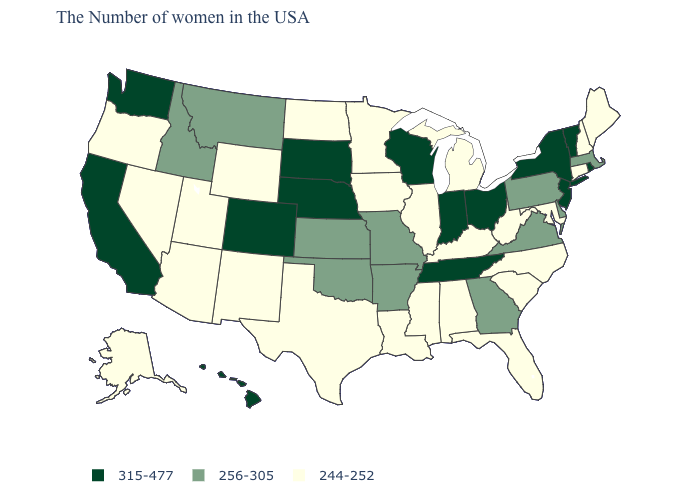What is the value of Maryland?
Answer briefly. 244-252. What is the value of Kansas?
Quick response, please. 256-305. Is the legend a continuous bar?
Write a very short answer. No. Name the states that have a value in the range 315-477?
Answer briefly. Rhode Island, Vermont, New York, New Jersey, Ohio, Indiana, Tennessee, Wisconsin, Nebraska, South Dakota, Colorado, California, Washington, Hawaii. Which states have the highest value in the USA?
Quick response, please. Rhode Island, Vermont, New York, New Jersey, Ohio, Indiana, Tennessee, Wisconsin, Nebraska, South Dakota, Colorado, California, Washington, Hawaii. Does Tennessee have the highest value in the South?
Give a very brief answer. Yes. Which states have the lowest value in the USA?
Short answer required. Maine, New Hampshire, Connecticut, Maryland, North Carolina, South Carolina, West Virginia, Florida, Michigan, Kentucky, Alabama, Illinois, Mississippi, Louisiana, Minnesota, Iowa, Texas, North Dakota, Wyoming, New Mexico, Utah, Arizona, Nevada, Oregon, Alaska. What is the lowest value in the USA?
Quick response, please. 244-252. What is the value of Arkansas?
Answer briefly. 256-305. Name the states that have a value in the range 244-252?
Keep it brief. Maine, New Hampshire, Connecticut, Maryland, North Carolina, South Carolina, West Virginia, Florida, Michigan, Kentucky, Alabama, Illinois, Mississippi, Louisiana, Minnesota, Iowa, Texas, North Dakota, Wyoming, New Mexico, Utah, Arizona, Nevada, Oregon, Alaska. Is the legend a continuous bar?
Answer briefly. No. Name the states that have a value in the range 244-252?
Quick response, please. Maine, New Hampshire, Connecticut, Maryland, North Carolina, South Carolina, West Virginia, Florida, Michigan, Kentucky, Alabama, Illinois, Mississippi, Louisiana, Minnesota, Iowa, Texas, North Dakota, Wyoming, New Mexico, Utah, Arizona, Nevada, Oregon, Alaska. Which states have the highest value in the USA?
Be succinct. Rhode Island, Vermont, New York, New Jersey, Ohio, Indiana, Tennessee, Wisconsin, Nebraska, South Dakota, Colorado, California, Washington, Hawaii. Does the first symbol in the legend represent the smallest category?
Quick response, please. No. What is the value of Minnesota?
Concise answer only. 244-252. 